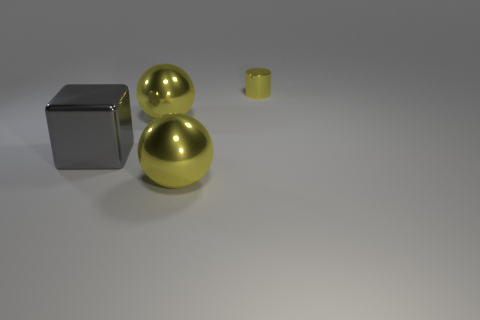What number of big spheres have the same color as the tiny cylinder?
Keep it short and to the point. 2. How many tiny green metallic spheres are there?
Offer a terse response. 0. How many large yellow balls have the same material as the yellow cylinder?
Keep it short and to the point. 2. What is the material of the gray block?
Keep it short and to the point. Metal. There is a yellow sphere behind the yellow object in front of the large metal ball that is behind the large shiny cube; what is it made of?
Give a very brief answer. Metal. Is there any other thing that has the same shape as the gray object?
Ensure brevity in your answer.  No. Do the big ball that is in front of the gray block and the large ball that is behind the metal cube have the same color?
Ensure brevity in your answer.  Yes. Are there more small shiny cylinders in front of the tiny metal cylinder than large gray shiny objects?
Provide a short and direct response. No. What number of other things are there of the same size as the yellow cylinder?
Make the answer very short. 0. How many large objects are behind the big gray shiny block and in front of the gray object?
Offer a very short reply. 0. 